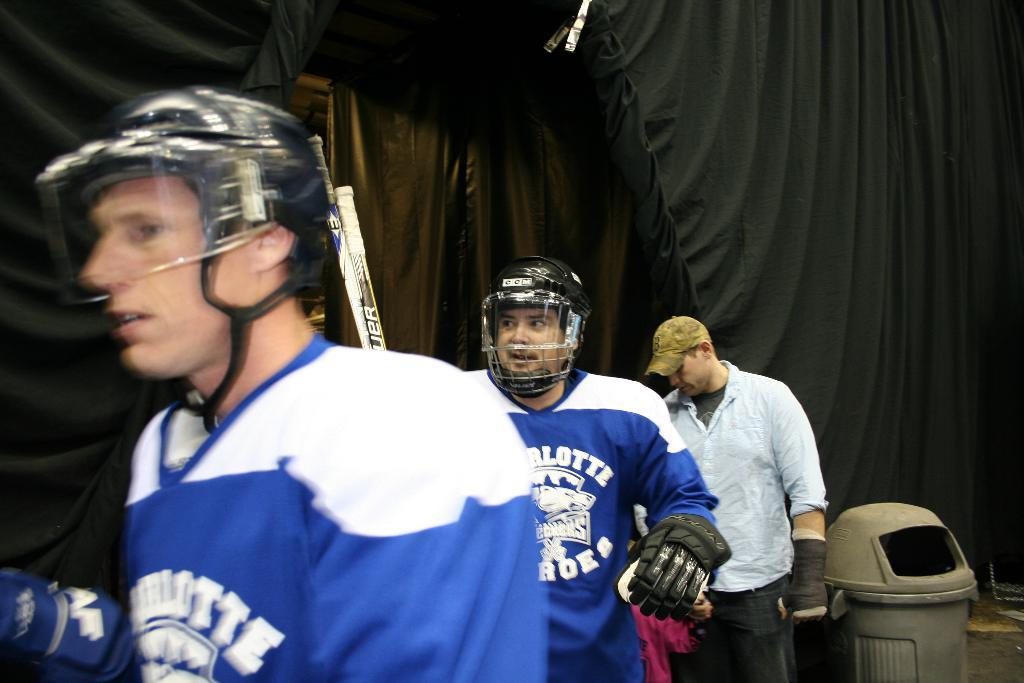How many people are in the image? There is a group of people in the image. What are the people doing in the image? The people are standing and holding bats in their hands. What protective gear are the people wearing? The people are wearing helmets. What can be seen in the background of the image? There is a bin in the background of the image. What is the color of the curtain in the image? There is a black curtain in the image. What type of weather can be seen in the image? The image does not show any weather conditions; it is focused on the group of people and their activities. 